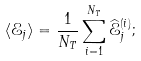Convert formula to latex. <formula><loc_0><loc_0><loc_500><loc_500>\langle \mathcal { E } _ { j } \rangle = \frac { 1 } { N _ { T } } \sum _ { i = 1 } ^ { N _ { T } } \widehat { \mathcal { E } } ^ { ( i ) } _ { j } ;</formula> 